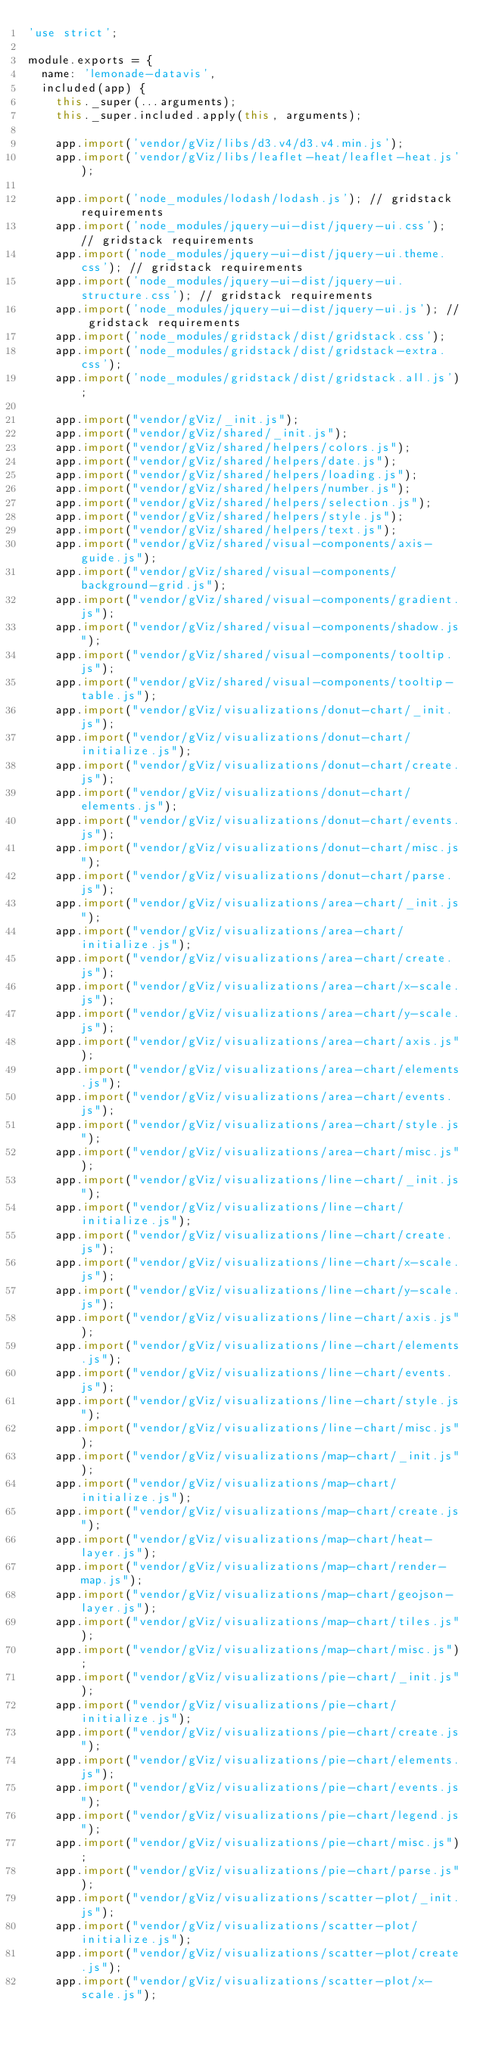Convert code to text. <code><loc_0><loc_0><loc_500><loc_500><_JavaScript_>'use strict';

module.exports = {
  name: 'lemonade-datavis',
  included(app) {
    this._super(...arguments);
    this._super.included.apply(this, arguments);

    app.import('vendor/gViz/libs/d3.v4/d3.v4.min.js');
    app.import('vendor/gViz/libs/leaflet-heat/leaflet-heat.js');

    app.import('node_modules/lodash/lodash.js'); // gridstack requirements
    app.import('node_modules/jquery-ui-dist/jquery-ui.css'); // gridstack requirements
    app.import('node_modules/jquery-ui-dist/jquery-ui.theme.css'); // gridstack requirements
    app.import('node_modules/jquery-ui-dist/jquery-ui.structure.css'); // gridstack requirements
    app.import('node_modules/jquery-ui-dist/jquery-ui.js'); // gridstack requirements
    app.import('node_modules/gridstack/dist/gridstack.css');
    app.import('node_modules/gridstack/dist/gridstack-extra.css');
    app.import('node_modules/gridstack/dist/gridstack.all.js');

    app.import("vendor/gViz/_init.js");
    app.import("vendor/gViz/shared/_init.js");
    app.import("vendor/gViz/shared/helpers/colors.js");
    app.import("vendor/gViz/shared/helpers/date.js");
    app.import("vendor/gViz/shared/helpers/loading.js");
    app.import("vendor/gViz/shared/helpers/number.js");
    app.import("vendor/gViz/shared/helpers/selection.js");
    app.import("vendor/gViz/shared/helpers/style.js");
    app.import("vendor/gViz/shared/helpers/text.js");
    app.import("vendor/gViz/shared/visual-components/axis-guide.js");
    app.import("vendor/gViz/shared/visual-components/background-grid.js");
    app.import("vendor/gViz/shared/visual-components/gradient.js");
    app.import("vendor/gViz/shared/visual-components/shadow.js");
    app.import("vendor/gViz/shared/visual-components/tooltip.js");
    app.import("vendor/gViz/shared/visual-components/tooltip-table.js");
    app.import("vendor/gViz/visualizations/donut-chart/_init.js");
    app.import("vendor/gViz/visualizations/donut-chart/initialize.js");
    app.import("vendor/gViz/visualizations/donut-chart/create.js");
    app.import("vendor/gViz/visualizations/donut-chart/elements.js");
    app.import("vendor/gViz/visualizations/donut-chart/events.js");
    app.import("vendor/gViz/visualizations/donut-chart/misc.js");
    app.import("vendor/gViz/visualizations/donut-chart/parse.js");
    app.import("vendor/gViz/visualizations/area-chart/_init.js");
    app.import("vendor/gViz/visualizations/area-chart/initialize.js");
    app.import("vendor/gViz/visualizations/area-chart/create.js");
    app.import("vendor/gViz/visualizations/area-chart/x-scale.js");
    app.import("vendor/gViz/visualizations/area-chart/y-scale.js");
    app.import("vendor/gViz/visualizations/area-chart/axis.js");
    app.import("vendor/gViz/visualizations/area-chart/elements.js");
    app.import("vendor/gViz/visualizations/area-chart/events.js");
    app.import("vendor/gViz/visualizations/area-chart/style.js");
    app.import("vendor/gViz/visualizations/area-chart/misc.js");
    app.import("vendor/gViz/visualizations/line-chart/_init.js");
    app.import("vendor/gViz/visualizations/line-chart/initialize.js");
    app.import("vendor/gViz/visualizations/line-chart/create.js");
    app.import("vendor/gViz/visualizations/line-chart/x-scale.js");
    app.import("vendor/gViz/visualizations/line-chart/y-scale.js");
    app.import("vendor/gViz/visualizations/line-chart/axis.js");
    app.import("vendor/gViz/visualizations/line-chart/elements.js");
    app.import("vendor/gViz/visualizations/line-chart/events.js");
    app.import("vendor/gViz/visualizations/line-chart/style.js");
    app.import("vendor/gViz/visualizations/line-chart/misc.js");
    app.import("vendor/gViz/visualizations/map-chart/_init.js");
    app.import("vendor/gViz/visualizations/map-chart/initialize.js");
    app.import("vendor/gViz/visualizations/map-chart/create.js");
    app.import("vendor/gViz/visualizations/map-chart/heat-layer.js");
    app.import("vendor/gViz/visualizations/map-chart/render-map.js");
    app.import("vendor/gViz/visualizations/map-chart/geojson-layer.js");
    app.import("vendor/gViz/visualizations/map-chart/tiles.js");
    app.import("vendor/gViz/visualizations/map-chart/misc.js");
    app.import("vendor/gViz/visualizations/pie-chart/_init.js");
    app.import("vendor/gViz/visualizations/pie-chart/initialize.js");
    app.import("vendor/gViz/visualizations/pie-chart/create.js");
    app.import("vendor/gViz/visualizations/pie-chart/elements.js");
    app.import("vendor/gViz/visualizations/pie-chart/events.js");
    app.import("vendor/gViz/visualizations/pie-chart/legend.js");
    app.import("vendor/gViz/visualizations/pie-chart/misc.js");
    app.import("vendor/gViz/visualizations/pie-chart/parse.js");
    app.import("vendor/gViz/visualizations/scatter-plot/_init.js");
    app.import("vendor/gViz/visualizations/scatter-plot/initialize.js");
    app.import("vendor/gViz/visualizations/scatter-plot/create.js");
    app.import("vendor/gViz/visualizations/scatter-plot/x-scale.js");</code> 